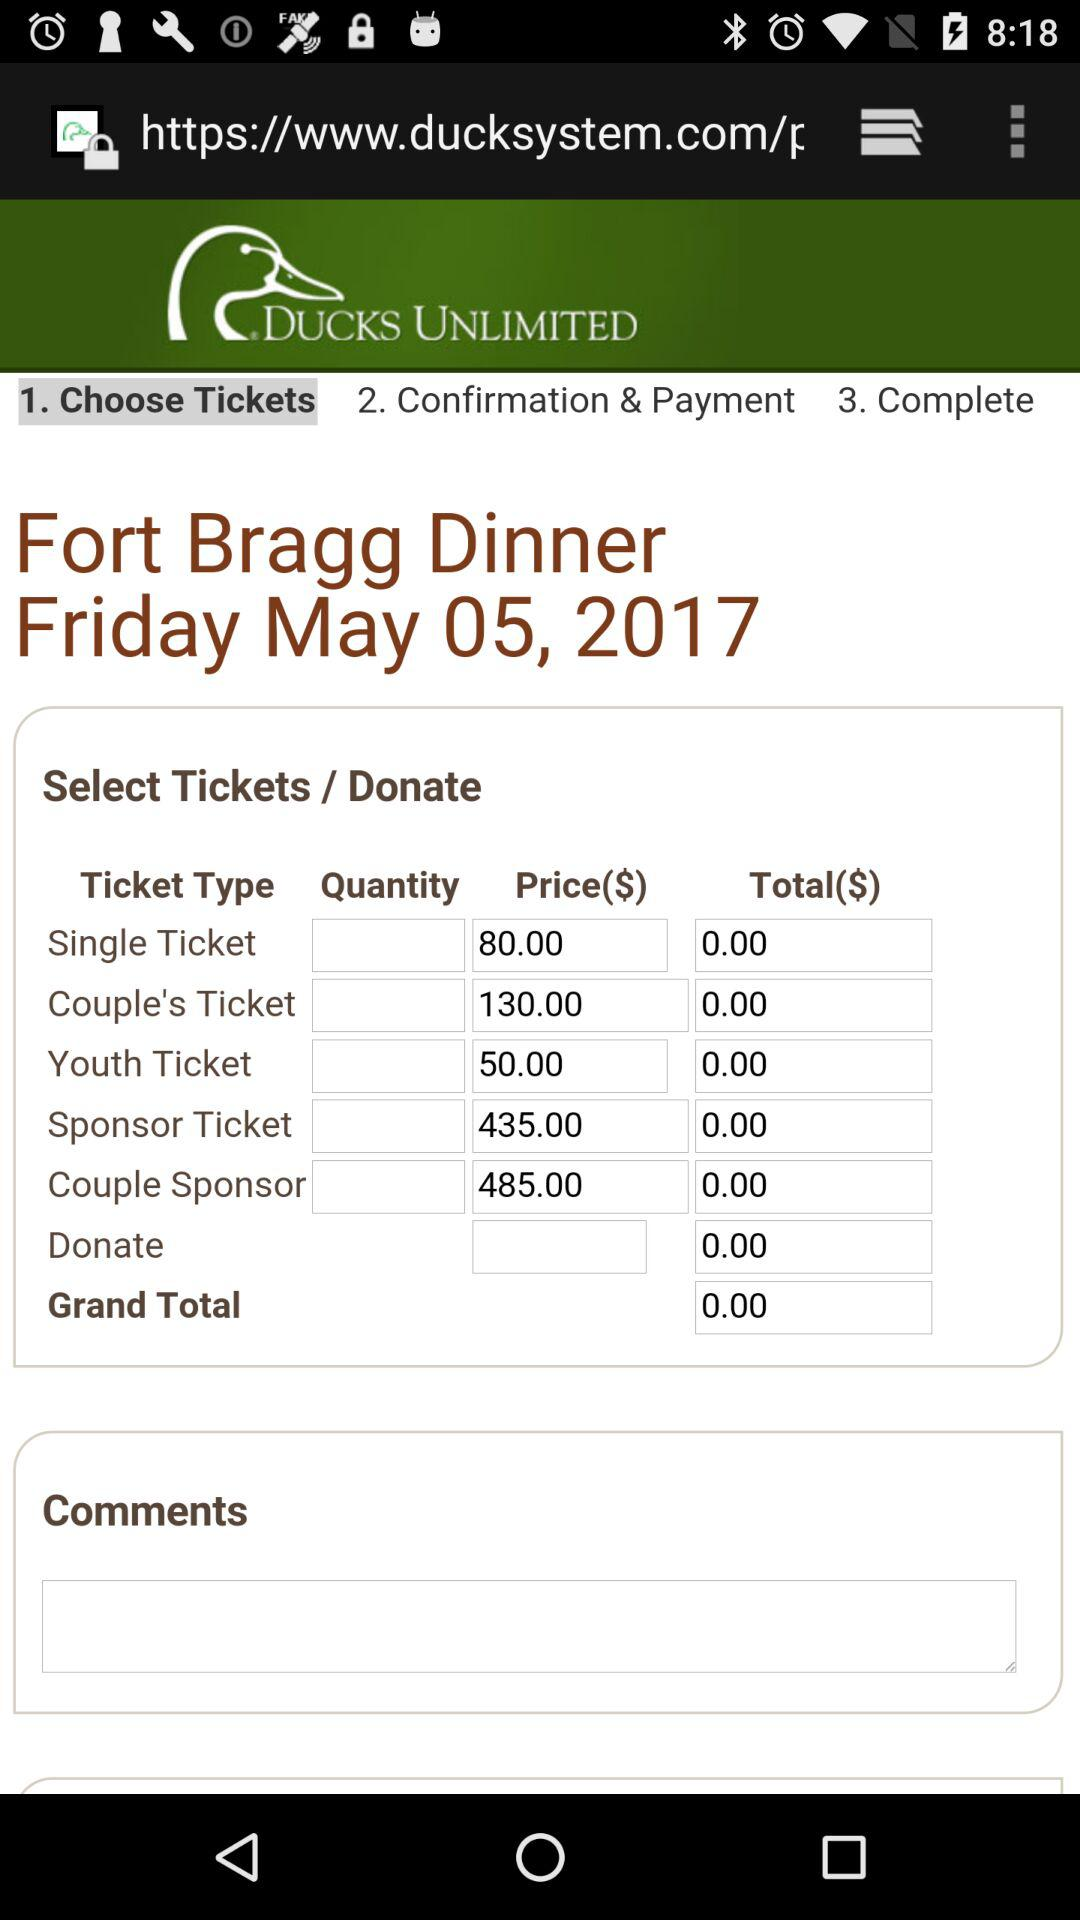What is the price for the "Couple's Ticket"? The price for the "Couple's Ticket" is 130.00. 